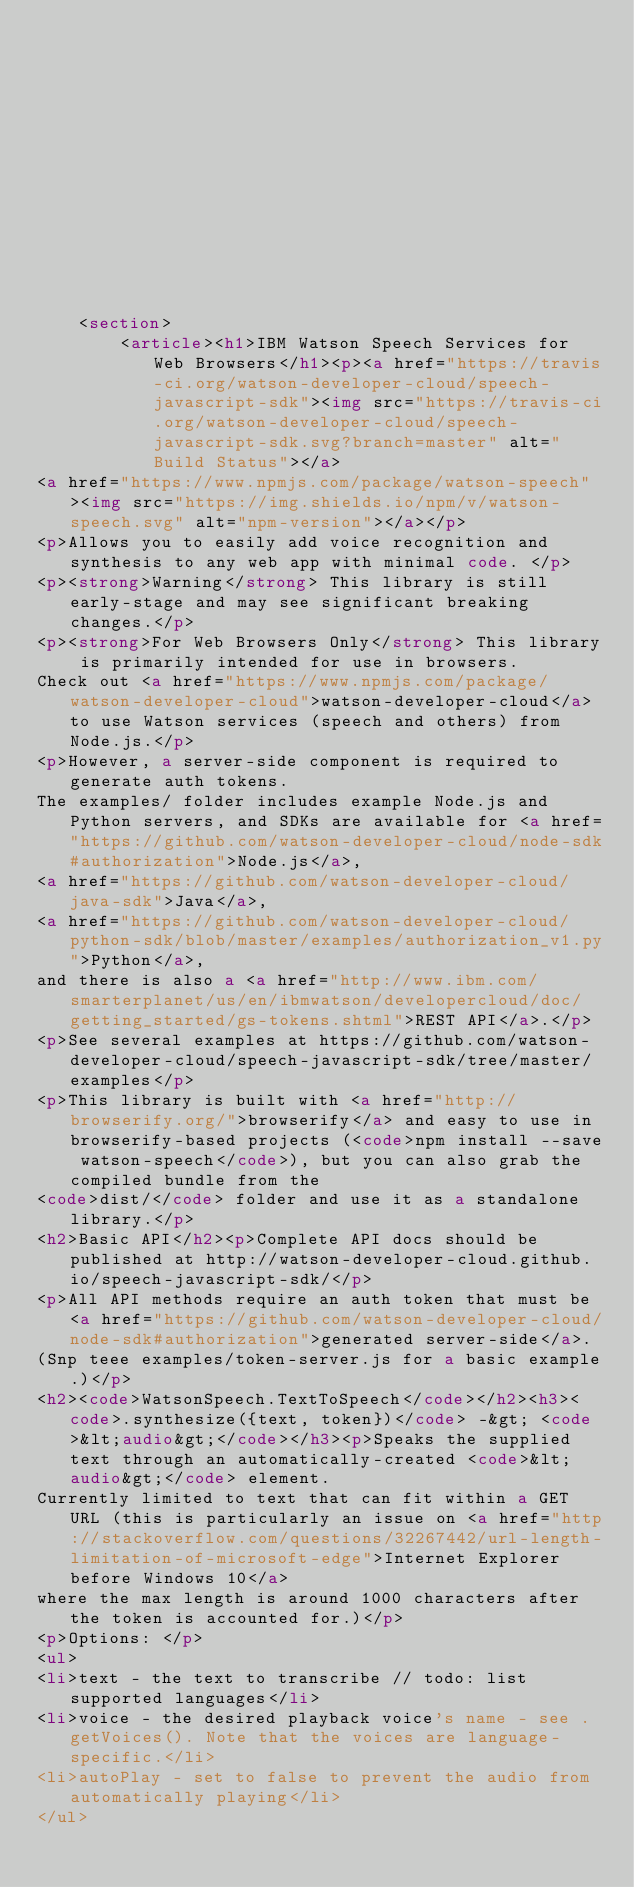<code> <loc_0><loc_0><loc_500><loc_500><_HTML_>








    




    <section>
        <article><h1>IBM Watson Speech Services for Web Browsers</h1><p><a href="https://travis-ci.org/watson-developer-cloud/speech-javascript-sdk"><img src="https://travis-ci.org/watson-developer-cloud/speech-javascript-sdk.svg?branch=master" alt="Build Status"></a>
<a href="https://www.npmjs.com/package/watson-speech"><img src="https://img.shields.io/npm/v/watson-speech.svg" alt="npm-version"></a></p>
<p>Allows you to easily add voice recognition and synthesis to any web app with minimal code. </p>
<p><strong>Warning</strong> This library is still early-stage and may see significant breaking changes.</p>
<p><strong>For Web Browsers Only</strong> This library is primarily intended for use in browsers. 
Check out <a href="https://www.npmjs.com/package/watson-developer-cloud">watson-developer-cloud</a> to use Watson services (speech and others) from Node.js.</p>
<p>However, a server-side component is required to generate auth tokens. 
The examples/ folder includes example Node.js and Python servers, and SDKs are available for <a href="https://github.com/watson-developer-cloud/node-sdk#authorization">Node.js</a>, 
<a href="https://github.com/watson-developer-cloud/java-sdk">Java</a>, 
<a href="https://github.com/watson-developer-cloud/python-sdk/blob/master/examples/authorization_v1.py">Python</a>, 
and there is also a <a href="http://www.ibm.com/smarterplanet/us/en/ibmwatson/developercloud/doc/getting_started/gs-tokens.shtml">REST API</a>.</p>
<p>See several examples at https://github.com/watson-developer-cloud/speech-javascript-sdk/tree/master/examples</p>
<p>This library is built with <a href="http://browserify.org/">browserify</a> and easy to use in browserify-based projects (<code>npm install --save watson-speech</code>), but you can also grab the compiled bundle from the 
<code>dist/</code> folder and use it as a standalone library.</p>
<h2>Basic API</h2><p>Complete API docs should be published at http://watson-developer-cloud.github.io/speech-javascript-sdk/</p>
<p>All API methods require an auth token that must be <a href="https://github.com/watson-developer-cloud/node-sdk#authorization">generated server-side</a>. 
(Snp teee examples/token-server.js for a basic example.)</p>
<h2><code>WatsonSpeech.TextToSpeech</code></h2><h3><code>.synthesize({text, token})</code> -&gt; <code>&lt;audio&gt;</code></h3><p>Speaks the supplied text through an automatically-created <code>&lt;audio&gt;</code> element. 
Currently limited to text that can fit within a GET URL (this is particularly an issue on <a href="http://stackoverflow.com/questions/32267442/url-length-limitation-of-microsoft-edge">Internet Explorer before Windows 10</a>
where the max length is around 1000 characters after the token is accounted for.)</p>
<p>Options: </p>
<ul>
<li>text - the text to transcribe // todo: list supported languages</li>
<li>voice - the desired playback voice's name - see .getVoices(). Note that the voices are language-specific.</li>
<li>autoPlay - set to false to prevent the audio from automatically playing</li>
</ul></code> 